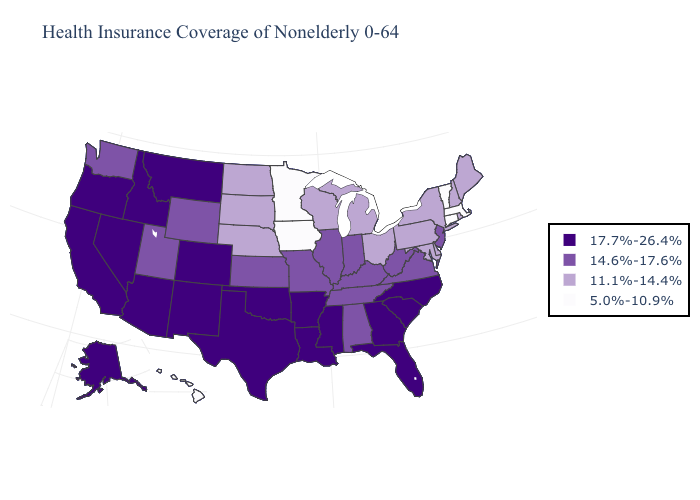Name the states that have a value in the range 11.1%-14.4%?
Write a very short answer. Delaware, Maine, Maryland, Michigan, Nebraska, New Hampshire, New York, North Dakota, Ohio, Pennsylvania, Rhode Island, South Dakota, Wisconsin. Name the states that have a value in the range 17.7%-26.4%?
Answer briefly. Alaska, Arizona, Arkansas, California, Colorado, Florida, Georgia, Idaho, Louisiana, Mississippi, Montana, Nevada, New Mexico, North Carolina, Oklahoma, Oregon, South Carolina, Texas. Among the states that border Oregon , does Nevada have the lowest value?
Quick response, please. No. What is the lowest value in states that border Oklahoma?
Keep it brief. 14.6%-17.6%. Name the states that have a value in the range 5.0%-10.9%?
Keep it brief. Connecticut, Hawaii, Iowa, Massachusetts, Minnesota, Vermont. What is the highest value in the USA?
Concise answer only. 17.7%-26.4%. How many symbols are there in the legend?
Answer briefly. 4. Which states have the lowest value in the Northeast?
Short answer required. Connecticut, Massachusetts, Vermont. Does Maryland have a lower value than Tennessee?
Be succinct. Yes. What is the value of New Mexico?
Short answer required. 17.7%-26.4%. Name the states that have a value in the range 14.6%-17.6%?
Keep it brief. Alabama, Illinois, Indiana, Kansas, Kentucky, Missouri, New Jersey, Tennessee, Utah, Virginia, Washington, West Virginia, Wyoming. Name the states that have a value in the range 17.7%-26.4%?
Write a very short answer. Alaska, Arizona, Arkansas, California, Colorado, Florida, Georgia, Idaho, Louisiana, Mississippi, Montana, Nevada, New Mexico, North Carolina, Oklahoma, Oregon, South Carolina, Texas. How many symbols are there in the legend?
Keep it brief. 4. What is the lowest value in the USA?
Be succinct. 5.0%-10.9%. Which states have the lowest value in the Northeast?
Short answer required. Connecticut, Massachusetts, Vermont. 